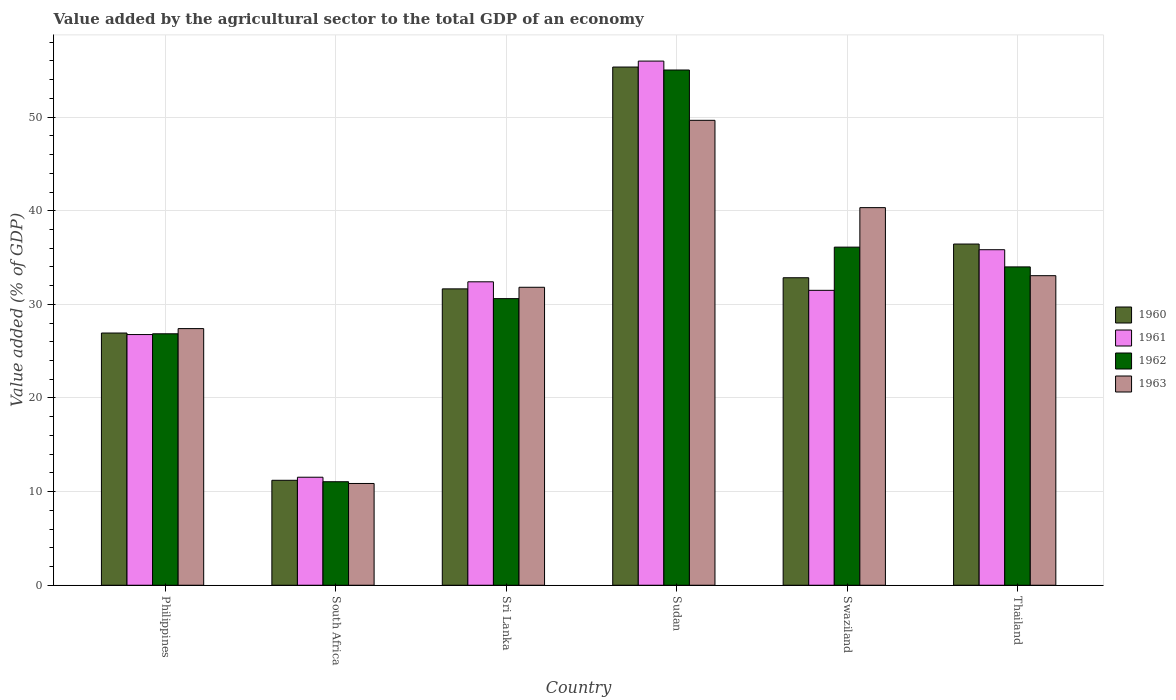Are the number of bars on each tick of the X-axis equal?
Make the answer very short. Yes. How many bars are there on the 5th tick from the left?
Your answer should be compact. 4. What is the label of the 4th group of bars from the left?
Offer a terse response. Sudan. In how many cases, is the number of bars for a given country not equal to the number of legend labels?
Your answer should be very brief. 0. What is the value added by the agricultural sector to the total GDP in 1962 in Swaziland?
Ensure brevity in your answer.  36.11. Across all countries, what is the maximum value added by the agricultural sector to the total GDP in 1963?
Give a very brief answer. 49.66. Across all countries, what is the minimum value added by the agricultural sector to the total GDP in 1961?
Offer a very short reply. 11.54. In which country was the value added by the agricultural sector to the total GDP in 1961 maximum?
Keep it short and to the point. Sudan. In which country was the value added by the agricultural sector to the total GDP in 1961 minimum?
Provide a short and direct response. South Africa. What is the total value added by the agricultural sector to the total GDP in 1960 in the graph?
Offer a terse response. 194.45. What is the difference between the value added by the agricultural sector to the total GDP in 1963 in Swaziland and that in Thailand?
Keep it short and to the point. 7.27. What is the difference between the value added by the agricultural sector to the total GDP in 1961 in South Africa and the value added by the agricultural sector to the total GDP in 1963 in Thailand?
Your response must be concise. -21.53. What is the average value added by the agricultural sector to the total GDP in 1961 per country?
Your answer should be very brief. 32.34. What is the difference between the value added by the agricultural sector to the total GDP of/in 1962 and value added by the agricultural sector to the total GDP of/in 1961 in Swaziland?
Your response must be concise. 4.61. In how many countries, is the value added by the agricultural sector to the total GDP in 1960 greater than 52 %?
Make the answer very short. 1. What is the ratio of the value added by the agricultural sector to the total GDP in 1960 in Philippines to that in Swaziland?
Keep it short and to the point. 0.82. Is the value added by the agricultural sector to the total GDP in 1963 in Philippines less than that in Sudan?
Provide a short and direct response. Yes. Is the difference between the value added by the agricultural sector to the total GDP in 1962 in South Africa and Sudan greater than the difference between the value added by the agricultural sector to the total GDP in 1961 in South Africa and Sudan?
Offer a terse response. Yes. What is the difference between the highest and the second highest value added by the agricultural sector to the total GDP in 1963?
Offer a very short reply. -9.32. What is the difference between the highest and the lowest value added by the agricultural sector to the total GDP in 1961?
Provide a succinct answer. 44.45. In how many countries, is the value added by the agricultural sector to the total GDP in 1961 greater than the average value added by the agricultural sector to the total GDP in 1961 taken over all countries?
Give a very brief answer. 3. Is it the case that in every country, the sum of the value added by the agricultural sector to the total GDP in 1963 and value added by the agricultural sector to the total GDP in 1962 is greater than the sum of value added by the agricultural sector to the total GDP in 1960 and value added by the agricultural sector to the total GDP in 1961?
Provide a succinct answer. No. What does the 1st bar from the left in Swaziland represents?
Keep it short and to the point. 1960. How many bars are there?
Your response must be concise. 24. What is the difference between two consecutive major ticks on the Y-axis?
Your response must be concise. 10. Does the graph contain grids?
Make the answer very short. Yes. Where does the legend appear in the graph?
Your answer should be very brief. Center right. How many legend labels are there?
Ensure brevity in your answer.  4. How are the legend labels stacked?
Give a very brief answer. Vertical. What is the title of the graph?
Provide a succinct answer. Value added by the agricultural sector to the total GDP of an economy. What is the label or title of the X-axis?
Provide a succinct answer. Country. What is the label or title of the Y-axis?
Ensure brevity in your answer.  Value added (% of GDP). What is the Value added (% of GDP) of 1960 in Philippines?
Your response must be concise. 26.94. What is the Value added (% of GDP) in 1961 in Philippines?
Offer a very short reply. 26.78. What is the Value added (% of GDP) of 1962 in Philippines?
Provide a short and direct response. 26.86. What is the Value added (% of GDP) in 1963 in Philippines?
Offer a very short reply. 27.41. What is the Value added (% of GDP) in 1960 in South Africa?
Your response must be concise. 11.21. What is the Value added (% of GDP) in 1961 in South Africa?
Give a very brief answer. 11.54. What is the Value added (% of GDP) of 1962 in South Africa?
Offer a terse response. 11.06. What is the Value added (% of GDP) of 1963 in South Africa?
Offer a terse response. 10.87. What is the Value added (% of GDP) in 1960 in Sri Lanka?
Offer a very short reply. 31.66. What is the Value added (% of GDP) of 1961 in Sri Lanka?
Make the answer very short. 32.41. What is the Value added (% of GDP) in 1962 in Sri Lanka?
Offer a terse response. 30.61. What is the Value added (% of GDP) of 1963 in Sri Lanka?
Provide a succinct answer. 31.83. What is the Value added (% of GDP) of 1960 in Sudan?
Your answer should be compact. 55.35. What is the Value added (% of GDP) of 1961 in Sudan?
Ensure brevity in your answer.  55.99. What is the Value added (% of GDP) in 1962 in Sudan?
Offer a very short reply. 55.03. What is the Value added (% of GDP) in 1963 in Sudan?
Offer a very short reply. 49.66. What is the Value added (% of GDP) of 1960 in Swaziland?
Ensure brevity in your answer.  32.84. What is the Value added (% of GDP) of 1961 in Swaziland?
Make the answer very short. 31.5. What is the Value added (% of GDP) of 1962 in Swaziland?
Your response must be concise. 36.11. What is the Value added (% of GDP) of 1963 in Swaziland?
Offer a very short reply. 40.33. What is the Value added (% of GDP) of 1960 in Thailand?
Provide a succinct answer. 36.44. What is the Value added (% of GDP) in 1961 in Thailand?
Your response must be concise. 35.84. What is the Value added (% of GDP) of 1962 in Thailand?
Your response must be concise. 34. What is the Value added (% of GDP) of 1963 in Thailand?
Your answer should be compact. 33.07. Across all countries, what is the maximum Value added (% of GDP) of 1960?
Your answer should be very brief. 55.35. Across all countries, what is the maximum Value added (% of GDP) of 1961?
Give a very brief answer. 55.99. Across all countries, what is the maximum Value added (% of GDP) of 1962?
Provide a short and direct response. 55.03. Across all countries, what is the maximum Value added (% of GDP) in 1963?
Provide a short and direct response. 49.66. Across all countries, what is the minimum Value added (% of GDP) of 1960?
Give a very brief answer. 11.21. Across all countries, what is the minimum Value added (% of GDP) of 1961?
Your answer should be very brief. 11.54. Across all countries, what is the minimum Value added (% of GDP) of 1962?
Make the answer very short. 11.06. Across all countries, what is the minimum Value added (% of GDP) of 1963?
Your response must be concise. 10.87. What is the total Value added (% of GDP) of 1960 in the graph?
Keep it short and to the point. 194.45. What is the total Value added (% of GDP) of 1961 in the graph?
Your response must be concise. 194.05. What is the total Value added (% of GDP) in 1962 in the graph?
Give a very brief answer. 193.68. What is the total Value added (% of GDP) in 1963 in the graph?
Your response must be concise. 193.16. What is the difference between the Value added (% of GDP) in 1960 in Philippines and that in South Africa?
Ensure brevity in your answer.  15.73. What is the difference between the Value added (% of GDP) in 1961 in Philippines and that in South Africa?
Provide a short and direct response. 15.24. What is the difference between the Value added (% of GDP) in 1962 in Philippines and that in South Africa?
Offer a terse response. 15.8. What is the difference between the Value added (% of GDP) of 1963 in Philippines and that in South Africa?
Make the answer very short. 16.54. What is the difference between the Value added (% of GDP) of 1960 in Philippines and that in Sri Lanka?
Your response must be concise. -4.72. What is the difference between the Value added (% of GDP) of 1961 in Philippines and that in Sri Lanka?
Make the answer very short. -5.63. What is the difference between the Value added (% of GDP) in 1962 in Philippines and that in Sri Lanka?
Offer a terse response. -3.76. What is the difference between the Value added (% of GDP) in 1963 in Philippines and that in Sri Lanka?
Keep it short and to the point. -4.41. What is the difference between the Value added (% of GDP) of 1960 in Philippines and that in Sudan?
Your answer should be compact. -28.41. What is the difference between the Value added (% of GDP) in 1961 in Philippines and that in Sudan?
Your answer should be very brief. -29.21. What is the difference between the Value added (% of GDP) of 1962 in Philippines and that in Sudan?
Your answer should be compact. -28.18. What is the difference between the Value added (% of GDP) in 1963 in Philippines and that in Sudan?
Offer a terse response. -22.25. What is the difference between the Value added (% of GDP) in 1960 in Philippines and that in Swaziland?
Provide a succinct answer. -5.9. What is the difference between the Value added (% of GDP) of 1961 in Philippines and that in Swaziland?
Offer a terse response. -4.72. What is the difference between the Value added (% of GDP) of 1962 in Philippines and that in Swaziland?
Provide a short and direct response. -9.26. What is the difference between the Value added (% of GDP) in 1963 in Philippines and that in Swaziland?
Your response must be concise. -12.92. What is the difference between the Value added (% of GDP) in 1960 in Philippines and that in Thailand?
Your answer should be compact. -9.5. What is the difference between the Value added (% of GDP) in 1961 in Philippines and that in Thailand?
Offer a terse response. -9.06. What is the difference between the Value added (% of GDP) in 1962 in Philippines and that in Thailand?
Your response must be concise. -7.14. What is the difference between the Value added (% of GDP) in 1963 in Philippines and that in Thailand?
Your answer should be compact. -5.65. What is the difference between the Value added (% of GDP) in 1960 in South Africa and that in Sri Lanka?
Your answer should be very brief. -20.45. What is the difference between the Value added (% of GDP) of 1961 in South Africa and that in Sri Lanka?
Your answer should be compact. -20.87. What is the difference between the Value added (% of GDP) in 1962 in South Africa and that in Sri Lanka?
Keep it short and to the point. -19.56. What is the difference between the Value added (% of GDP) in 1963 in South Africa and that in Sri Lanka?
Offer a terse response. -20.96. What is the difference between the Value added (% of GDP) in 1960 in South Africa and that in Sudan?
Provide a succinct answer. -44.14. What is the difference between the Value added (% of GDP) in 1961 in South Africa and that in Sudan?
Your response must be concise. -44.45. What is the difference between the Value added (% of GDP) in 1962 in South Africa and that in Sudan?
Make the answer very short. -43.98. What is the difference between the Value added (% of GDP) of 1963 in South Africa and that in Sudan?
Your response must be concise. -38.79. What is the difference between the Value added (% of GDP) of 1960 in South Africa and that in Swaziland?
Your response must be concise. -21.63. What is the difference between the Value added (% of GDP) in 1961 in South Africa and that in Swaziland?
Provide a short and direct response. -19.96. What is the difference between the Value added (% of GDP) in 1962 in South Africa and that in Swaziland?
Ensure brevity in your answer.  -25.06. What is the difference between the Value added (% of GDP) of 1963 in South Africa and that in Swaziland?
Ensure brevity in your answer.  -29.46. What is the difference between the Value added (% of GDP) in 1960 in South Africa and that in Thailand?
Keep it short and to the point. -25.23. What is the difference between the Value added (% of GDP) in 1961 in South Africa and that in Thailand?
Offer a terse response. -24.3. What is the difference between the Value added (% of GDP) of 1962 in South Africa and that in Thailand?
Your response must be concise. -22.95. What is the difference between the Value added (% of GDP) in 1963 in South Africa and that in Thailand?
Provide a short and direct response. -22.2. What is the difference between the Value added (% of GDP) in 1960 in Sri Lanka and that in Sudan?
Offer a terse response. -23.7. What is the difference between the Value added (% of GDP) of 1961 in Sri Lanka and that in Sudan?
Your answer should be very brief. -23.58. What is the difference between the Value added (% of GDP) of 1962 in Sri Lanka and that in Sudan?
Give a very brief answer. -24.42. What is the difference between the Value added (% of GDP) of 1963 in Sri Lanka and that in Sudan?
Keep it short and to the point. -17.83. What is the difference between the Value added (% of GDP) of 1960 in Sri Lanka and that in Swaziland?
Keep it short and to the point. -1.19. What is the difference between the Value added (% of GDP) of 1961 in Sri Lanka and that in Swaziland?
Your response must be concise. 0.91. What is the difference between the Value added (% of GDP) in 1962 in Sri Lanka and that in Swaziland?
Offer a terse response. -5.5. What is the difference between the Value added (% of GDP) in 1963 in Sri Lanka and that in Swaziland?
Your answer should be very brief. -8.51. What is the difference between the Value added (% of GDP) in 1960 in Sri Lanka and that in Thailand?
Ensure brevity in your answer.  -4.79. What is the difference between the Value added (% of GDP) in 1961 in Sri Lanka and that in Thailand?
Your answer should be compact. -3.43. What is the difference between the Value added (% of GDP) of 1962 in Sri Lanka and that in Thailand?
Your response must be concise. -3.39. What is the difference between the Value added (% of GDP) in 1963 in Sri Lanka and that in Thailand?
Offer a terse response. -1.24. What is the difference between the Value added (% of GDP) in 1960 in Sudan and that in Swaziland?
Provide a succinct answer. 22.51. What is the difference between the Value added (% of GDP) of 1961 in Sudan and that in Swaziland?
Your answer should be compact. 24.49. What is the difference between the Value added (% of GDP) in 1962 in Sudan and that in Swaziland?
Your response must be concise. 18.92. What is the difference between the Value added (% of GDP) in 1963 in Sudan and that in Swaziland?
Provide a short and direct response. 9.32. What is the difference between the Value added (% of GDP) in 1960 in Sudan and that in Thailand?
Your answer should be very brief. 18.91. What is the difference between the Value added (% of GDP) in 1961 in Sudan and that in Thailand?
Keep it short and to the point. 20.15. What is the difference between the Value added (% of GDP) in 1962 in Sudan and that in Thailand?
Ensure brevity in your answer.  21.03. What is the difference between the Value added (% of GDP) of 1963 in Sudan and that in Thailand?
Give a very brief answer. 16.59. What is the difference between the Value added (% of GDP) of 1960 in Swaziland and that in Thailand?
Make the answer very short. -3.6. What is the difference between the Value added (% of GDP) of 1961 in Swaziland and that in Thailand?
Your response must be concise. -4.34. What is the difference between the Value added (% of GDP) in 1962 in Swaziland and that in Thailand?
Keep it short and to the point. 2.11. What is the difference between the Value added (% of GDP) of 1963 in Swaziland and that in Thailand?
Your response must be concise. 7.27. What is the difference between the Value added (% of GDP) of 1960 in Philippines and the Value added (% of GDP) of 1961 in South Africa?
Your response must be concise. 15.4. What is the difference between the Value added (% of GDP) in 1960 in Philippines and the Value added (% of GDP) in 1962 in South Africa?
Your answer should be very brief. 15.88. What is the difference between the Value added (% of GDP) of 1960 in Philippines and the Value added (% of GDP) of 1963 in South Africa?
Make the answer very short. 16.07. What is the difference between the Value added (% of GDP) in 1961 in Philippines and the Value added (% of GDP) in 1962 in South Africa?
Ensure brevity in your answer.  15.72. What is the difference between the Value added (% of GDP) of 1961 in Philippines and the Value added (% of GDP) of 1963 in South Africa?
Offer a very short reply. 15.91. What is the difference between the Value added (% of GDP) in 1962 in Philippines and the Value added (% of GDP) in 1963 in South Africa?
Keep it short and to the point. 15.99. What is the difference between the Value added (% of GDP) of 1960 in Philippines and the Value added (% of GDP) of 1961 in Sri Lanka?
Make the answer very short. -5.47. What is the difference between the Value added (% of GDP) of 1960 in Philippines and the Value added (% of GDP) of 1962 in Sri Lanka?
Your response must be concise. -3.67. What is the difference between the Value added (% of GDP) of 1960 in Philippines and the Value added (% of GDP) of 1963 in Sri Lanka?
Give a very brief answer. -4.89. What is the difference between the Value added (% of GDP) of 1961 in Philippines and the Value added (% of GDP) of 1962 in Sri Lanka?
Make the answer very short. -3.84. What is the difference between the Value added (% of GDP) of 1961 in Philippines and the Value added (% of GDP) of 1963 in Sri Lanka?
Your answer should be compact. -5.05. What is the difference between the Value added (% of GDP) of 1962 in Philippines and the Value added (% of GDP) of 1963 in Sri Lanka?
Ensure brevity in your answer.  -4.97. What is the difference between the Value added (% of GDP) in 1960 in Philippines and the Value added (% of GDP) in 1961 in Sudan?
Provide a succinct answer. -29.05. What is the difference between the Value added (% of GDP) in 1960 in Philippines and the Value added (% of GDP) in 1962 in Sudan?
Offer a very short reply. -28.09. What is the difference between the Value added (% of GDP) of 1960 in Philippines and the Value added (% of GDP) of 1963 in Sudan?
Your answer should be compact. -22.72. What is the difference between the Value added (% of GDP) in 1961 in Philippines and the Value added (% of GDP) in 1962 in Sudan?
Give a very brief answer. -28.26. What is the difference between the Value added (% of GDP) of 1961 in Philippines and the Value added (% of GDP) of 1963 in Sudan?
Ensure brevity in your answer.  -22.88. What is the difference between the Value added (% of GDP) in 1962 in Philippines and the Value added (% of GDP) in 1963 in Sudan?
Your answer should be compact. -22.8. What is the difference between the Value added (% of GDP) of 1960 in Philippines and the Value added (% of GDP) of 1961 in Swaziland?
Offer a very short reply. -4.56. What is the difference between the Value added (% of GDP) in 1960 in Philippines and the Value added (% of GDP) in 1962 in Swaziland?
Give a very brief answer. -9.17. What is the difference between the Value added (% of GDP) in 1960 in Philippines and the Value added (% of GDP) in 1963 in Swaziland?
Your answer should be compact. -13.39. What is the difference between the Value added (% of GDP) in 1961 in Philippines and the Value added (% of GDP) in 1962 in Swaziland?
Keep it short and to the point. -9.34. What is the difference between the Value added (% of GDP) in 1961 in Philippines and the Value added (% of GDP) in 1963 in Swaziland?
Make the answer very short. -13.56. What is the difference between the Value added (% of GDP) of 1962 in Philippines and the Value added (% of GDP) of 1963 in Swaziland?
Your response must be concise. -13.48. What is the difference between the Value added (% of GDP) in 1960 in Philippines and the Value added (% of GDP) in 1961 in Thailand?
Offer a terse response. -8.9. What is the difference between the Value added (% of GDP) in 1960 in Philippines and the Value added (% of GDP) in 1962 in Thailand?
Offer a very short reply. -7.06. What is the difference between the Value added (% of GDP) in 1960 in Philippines and the Value added (% of GDP) in 1963 in Thailand?
Provide a short and direct response. -6.12. What is the difference between the Value added (% of GDP) in 1961 in Philippines and the Value added (% of GDP) in 1962 in Thailand?
Your answer should be compact. -7.23. What is the difference between the Value added (% of GDP) in 1961 in Philippines and the Value added (% of GDP) in 1963 in Thailand?
Ensure brevity in your answer.  -6.29. What is the difference between the Value added (% of GDP) in 1962 in Philippines and the Value added (% of GDP) in 1963 in Thailand?
Ensure brevity in your answer.  -6.21. What is the difference between the Value added (% of GDP) of 1960 in South Africa and the Value added (% of GDP) of 1961 in Sri Lanka?
Provide a short and direct response. -21.2. What is the difference between the Value added (% of GDP) of 1960 in South Africa and the Value added (% of GDP) of 1962 in Sri Lanka?
Ensure brevity in your answer.  -19.4. What is the difference between the Value added (% of GDP) in 1960 in South Africa and the Value added (% of GDP) in 1963 in Sri Lanka?
Give a very brief answer. -20.62. What is the difference between the Value added (% of GDP) of 1961 in South Africa and the Value added (% of GDP) of 1962 in Sri Lanka?
Give a very brief answer. -19.08. What is the difference between the Value added (% of GDP) of 1961 in South Africa and the Value added (% of GDP) of 1963 in Sri Lanka?
Provide a short and direct response. -20.29. What is the difference between the Value added (% of GDP) of 1962 in South Africa and the Value added (% of GDP) of 1963 in Sri Lanka?
Your answer should be compact. -20.77. What is the difference between the Value added (% of GDP) of 1960 in South Africa and the Value added (% of GDP) of 1961 in Sudan?
Your answer should be very brief. -44.78. What is the difference between the Value added (% of GDP) in 1960 in South Africa and the Value added (% of GDP) in 1962 in Sudan?
Keep it short and to the point. -43.82. What is the difference between the Value added (% of GDP) of 1960 in South Africa and the Value added (% of GDP) of 1963 in Sudan?
Keep it short and to the point. -38.45. What is the difference between the Value added (% of GDP) in 1961 in South Africa and the Value added (% of GDP) in 1962 in Sudan?
Provide a succinct answer. -43.5. What is the difference between the Value added (% of GDP) in 1961 in South Africa and the Value added (% of GDP) in 1963 in Sudan?
Your answer should be very brief. -38.12. What is the difference between the Value added (% of GDP) of 1962 in South Africa and the Value added (% of GDP) of 1963 in Sudan?
Your answer should be very brief. -38.6. What is the difference between the Value added (% of GDP) of 1960 in South Africa and the Value added (% of GDP) of 1961 in Swaziland?
Give a very brief answer. -20.29. What is the difference between the Value added (% of GDP) in 1960 in South Africa and the Value added (% of GDP) in 1962 in Swaziland?
Give a very brief answer. -24.9. What is the difference between the Value added (% of GDP) in 1960 in South Africa and the Value added (% of GDP) in 1963 in Swaziland?
Ensure brevity in your answer.  -29.12. What is the difference between the Value added (% of GDP) of 1961 in South Africa and the Value added (% of GDP) of 1962 in Swaziland?
Offer a terse response. -24.58. What is the difference between the Value added (% of GDP) of 1961 in South Africa and the Value added (% of GDP) of 1963 in Swaziland?
Your response must be concise. -28.8. What is the difference between the Value added (% of GDP) in 1962 in South Africa and the Value added (% of GDP) in 1963 in Swaziland?
Provide a succinct answer. -29.28. What is the difference between the Value added (% of GDP) of 1960 in South Africa and the Value added (% of GDP) of 1961 in Thailand?
Give a very brief answer. -24.63. What is the difference between the Value added (% of GDP) of 1960 in South Africa and the Value added (% of GDP) of 1962 in Thailand?
Provide a short and direct response. -22.79. What is the difference between the Value added (% of GDP) in 1960 in South Africa and the Value added (% of GDP) in 1963 in Thailand?
Keep it short and to the point. -21.86. What is the difference between the Value added (% of GDP) of 1961 in South Africa and the Value added (% of GDP) of 1962 in Thailand?
Your response must be concise. -22.47. What is the difference between the Value added (% of GDP) of 1961 in South Africa and the Value added (% of GDP) of 1963 in Thailand?
Make the answer very short. -21.53. What is the difference between the Value added (% of GDP) of 1962 in South Africa and the Value added (% of GDP) of 1963 in Thailand?
Keep it short and to the point. -22.01. What is the difference between the Value added (% of GDP) in 1960 in Sri Lanka and the Value added (% of GDP) in 1961 in Sudan?
Keep it short and to the point. -24.33. What is the difference between the Value added (% of GDP) in 1960 in Sri Lanka and the Value added (% of GDP) in 1962 in Sudan?
Keep it short and to the point. -23.38. What is the difference between the Value added (% of GDP) in 1960 in Sri Lanka and the Value added (% of GDP) in 1963 in Sudan?
Provide a succinct answer. -18. What is the difference between the Value added (% of GDP) of 1961 in Sri Lanka and the Value added (% of GDP) of 1962 in Sudan?
Provide a succinct answer. -22.62. What is the difference between the Value added (% of GDP) of 1961 in Sri Lanka and the Value added (% of GDP) of 1963 in Sudan?
Your answer should be compact. -17.25. What is the difference between the Value added (% of GDP) in 1962 in Sri Lanka and the Value added (% of GDP) in 1963 in Sudan?
Provide a succinct answer. -19.04. What is the difference between the Value added (% of GDP) in 1960 in Sri Lanka and the Value added (% of GDP) in 1961 in Swaziland?
Your answer should be very brief. 0.16. What is the difference between the Value added (% of GDP) in 1960 in Sri Lanka and the Value added (% of GDP) in 1962 in Swaziland?
Provide a succinct answer. -4.46. What is the difference between the Value added (% of GDP) in 1960 in Sri Lanka and the Value added (% of GDP) in 1963 in Swaziland?
Keep it short and to the point. -8.68. What is the difference between the Value added (% of GDP) in 1961 in Sri Lanka and the Value added (% of GDP) in 1962 in Swaziland?
Keep it short and to the point. -3.7. What is the difference between the Value added (% of GDP) in 1961 in Sri Lanka and the Value added (% of GDP) in 1963 in Swaziland?
Make the answer very short. -7.92. What is the difference between the Value added (% of GDP) in 1962 in Sri Lanka and the Value added (% of GDP) in 1963 in Swaziland?
Ensure brevity in your answer.  -9.72. What is the difference between the Value added (% of GDP) of 1960 in Sri Lanka and the Value added (% of GDP) of 1961 in Thailand?
Provide a short and direct response. -4.18. What is the difference between the Value added (% of GDP) of 1960 in Sri Lanka and the Value added (% of GDP) of 1962 in Thailand?
Ensure brevity in your answer.  -2.35. What is the difference between the Value added (% of GDP) in 1960 in Sri Lanka and the Value added (% of GDP) in 1963 in Thailand?
Your response must be concise. -1.41. What is the difference between the Value added (% of GDP) of 1961 in Sri Lanka and the Value added (% of GDP) of 1962 in Thailand?
Ensure brevity in your answer.  -1.59. What is the difference between the Value added (% of GDP) of 1961 in Sri Lanka and the Value added (% of GDP) of 1963 in Thailand?
Ensure brevity in your answer.  -0.65. What is the difference between the Value added (% of GDP) in 1962 in Sri Lanka and the Value added (% of GDP) in 1963 in Thailand?
Give a very brief answer. -2.45. What is the difference between the Value added (% of GDP) of 1960 in Sudan and the Value added (% of GDP) of 1961 in Swaziland?
Ensure brevity in your answer.  23.85. What is the difference between the Value added (% of GDP) of 1960 in Sudan and the Value added (% of GDP) of 1962 in Swaziland?
Offer a terse response. 19.24. What is the difference between the Value added (% of GDP) of 1960 in Sudan and the Value added (% of GDP) of 1963 in Swaziland?
Offer a terse response. 15.02. What is the difference between the Value added (% of GDP) in 1961 in Sudan and the Value added (% of GDP) in 1962 in Swaziland?
Ensure brevity in your answer.  19.87. What is the difference between the Value added (% of GDP) of 1961 in Sudan and the Value added (% of GDP) of 1963 in Swaziland?
Your answer should be compact. 15.65. What is the difference between the Value added (% of GDP) in 1962 in Sudan and the Value added (% of GDP) in 1963 in Swaziland?
Give a very brief answer. 14.7. What is the difference between the Value added (% of GDP) of 1960 in Sudan and the Value added (% of GDP) of 1961 in Thailand?
Provide a short and direct response. 19.51. What is the difference between the Value added (% of GDP) in 1960 in Sudan and the Value added (% of GDP) in 1962 in Thailand?
Provide a succinct answer. 21.35. What is the difference between the Value added (% of GDP) of 1960 in Sudan and the Value added (% of GDP) of 1963 in Thailand?
Give a very brief answer. 22.29. What is the difference between the Value added (% of GDP) of 1961 in Sudan and the Value added (% of GDP) of 1962 in Thailand?
Offer a terse response. 21.98. What is the difference between the Value added (% of GDP) in 1961 in Sudan and the Value added (% of GDP) in 1963 in Thailand?
Offer a terse response. 22.92. What is the difference between the Value added (% of GDP) of 1962 in Sudan and the Value added (% of GDP) of 1963 in Thailand?
Offer a very short reply. 21.97. What is the difference between the Value added (% of GDP) of 1960 in Swaziland and the Value added (% of GDP) of 1961 in Thailand?
Ensure brevity in your answer.  -2.99. What is the difference between the Value added (% of GDP) in 1960 in Swaziland and the Value added (% of GDP) in 1962 in Thailand?
Your answer should be very brief. -1.16. What is the difference between the Value added (% of GDP) in 1960 in Swaziland and the Value added (% of GDP) in 1963 in Thailand?
Make the answer very short. -0.22. What is the difference between the Value added (% of GDP) in 1961 in Swaziland and the Value added (% of GDP) in 1962 in Thailand?
Provide a succinct answer. -2.5. What is the difference between the Value added (% of GDP) of 1961 in Swaziland and the Value added (% of GDP) of 1963 in Thailand?
Your answer should be compact. -1.57. What is the difference between the Value added (% of GDP) of 1962 in Swaziland and the Value added (% of GDP) of 1963 in Thailand?
Keep it short and to the point. 3.05. What is the average Value added (% of GDP) in 1960 per country?
Provide a short and direct response. 32.41. What is the average Value added (% of GDP) of 1961 per country?
Your answer should be compact. 32.34. What is the average Value added (% of GDP) in 1962 per country?
Provide a succinct answer. 32.28. What is the average Value added (% of GDP) in 1963 per country?
Offer a very short reply. 32.19. What is the difference between the Value added (% of GDP) of 1960 and Value added (% of GDP) of 1961 in Philippines?
Make the answer very short. 0.16. What is the difference between the Value added (% of GDP) of 1960 and Value added (% of GDP) of 1962 in Philippines?
Keep it short and to the point. 0.08. What is the difference between the Value added (% of GDP) of 1960 and Value added (% of GDP) of 1963 in Philippines?
Offer a very short reply. -0.47. What is the difference between the Value added (% of GDP) of 1961 and Value added (% of GDP) of 1962 in Philippines?
Keep it short and to the point. -0.08. What is the difference between the Value added (% of GDP) in 1961 and Value added (% of GDP) in 1963 in Philippines?
Make the answer very short. -0.64. What is the difference between the Value added (% of GDP) in 1962 and Value added (% of GDP) in 1963 in Philippines?
Your answer should be very brief. -0.55. What is the difference between the Value added (% of GDP) in 1960 and Value added (% of GDP) in 1961 in South Africa?
Make the answer very short. -0.33. What is the difference between the Value added (% of GDP) in 1960 and Value added (% of GDP) in 1962 in South Africa?
Keep it short and to the point. 0.15. What is the difference between the Value added (% of GDP) of 1960 and Value added (% of GDP) of 1963 in South Africa?
Your answer should be very brief. 0.34. What is the difference between the Value added (% of GDP) of 1961 and Value added (% of GDP) of 1962 in South Africa?
Make the answer very short. 0.48. What is the difference between the Value added (% of GDP) of 1961 and Value added (% of GDP) of 1963 in South Africa?
Your response must be concise. 0.67. What is the difference between the Value added (% of GDP) in 1962 and Value added (% of GDP) in 1963 in South Africa?
Your answer should be compact. 0.19. What is the difference between the Value added (% of GDP) in 1960 and Value added (% of GDP) in 1961 in Sri Lanka?
Your response must be concise. -0.76. What is the difference between the Value added (% of GDP) in 1960 and Value added (% of GDP) in 1962 in Sri Lanka?
Ensure brevity in your answer.  1.04. What is the difference between the Value added (% of GDP) of 1960 and Value added (% of GDP) of 1963 in Sri Lanka?
Make the answer very short. -0.17. What is the difference between the Value added (% of GDP) in 1961 and Value added (% of GDP) in 1962 in Sri Lanka?
Give a very brief answer. 1.8. What is the difference between the Value added (% of GDP) in 1961 and Value added (% of GDP) in 1963 in Sri Lanka?
Keep it short and to the point. 0.59. What is the difference between the Value added (% of GDP) of 1962 and Value added (% of GDP) of 1963 in Sri Lanka?
Offer a very short reply. -1.21. What is the difference between the Value added (% of GDP) in 1960 and Value added (% of GDP) in 1961 in Sudan?
Your answer should be compact. -0.64. What is the difference between the Value added (% of GDP) of 1960 and Value added (% of GDP) of 1962 in Sudan?
Offer a terse response. 0.32. What is the difference between the Value added (% of GDP) of 1960 and Value added (% of GDP) of 1963 in Sudan?
Offer a terse response. 5.69. What is the difference between the Value added (% of GDP) of 1961 and Value added (% of GDP) of 1962 in Sudan?
Ensure brevity in your answer.  0.95. What is the difference between the Value added (% of GDP) in 1961 and Value added (% of GDP) in 1963 in Sudan?
Provide a short and direct response. 6.33. What is the difference between the Value added (% of GDP) of 1962 and Value added (% of GDP) of 1963 in Sudan?
Give a very brief answer. 5.37. What is the difference between the Value added (% of GDP) of 1960 and Value added (% of GDP) of 1961 in Swaziland?
Make the answer very short. 1.35. What is the difference between the Value added (% of GDP) in 1960 and Value added (% of GDP) in 1962 in Swaziland?
Offer a very short reply. -3.27. What is the difference between the Value added (% of GDP) in 1960 and Value added (% of GDP) in 1963 in Swaziland?
Your response must be concise. -7.49. What is the difference between the Value added (% of GDP) in 1961 and Value added (% of GDP) in 1962 in Swaziland?
Your answer should be very brief. -4.61. What is the difference between the Value added (% of GDP) of 1961 and Value added (% of GDP) of 1963 in Swaziland?
Provide a short and direct response. -8.83. What is the difference between the Value added (% of GDP) in 1962 and Value added (% of GDP) in 1963 in Swaziland?
Provide a succinct answer. -4.22. What is the difference between the Value added (% of GDP) of 1960 and Value added (% of GDP) of 1961 in Thailand?
Provide a succinct answer. 0.61. What is the difference between the Value added (% of GDP) of 1960 and Value added (% of GDP) of 1962 in Thailand?
Give a very brief answer. 2.44. What is the difference between the Value added (% of GDP) of 1960 and Value added (% of GDP) of 1963 in Thailand?
Your answer should be compact. 3.38. What is the difference between the Value added (% of GDP) of 1961 and Value added (% of GDP) of 1962 in Thailand?
Make the answer very short. 1.84. What is the difference between the Value added (% of GDP) of 1961 and Value added (% of GDP) of 1963 in Thailand?
Keep it short and to the point. 2.77. What is the difference between the Value added (% of GDP) of 1962 and Value added (% of GDP) of 1963 in Thailand?
Ensure brevity in your answer.  0.94. What is the ratio of the Value added (% of GDP) in 1960 in Philippines to that in South Africa?
Your response must be concise. 2.4. What is the ratio of the Value added (% of GDP) of 1961 in Philippines to that in South Africa?
Your answer should be compact. 2.32. What is the ratio of the Value added (% of GDP) of 1962 in Philippines to that in South Africa?
Give a very brief answer. 2.43. What is the ratio of the Value added (% of GDP) in 1963 in Philippines to that in South Africa?
Provide a succinct answer. 2.52. What is the ratio of the Value added (% of GDP) in 1960 in Philippines to that in Sri Lanka?
Keep it short and to the point. 0.85. What is the ratio of the Value added (% of GDP) in 1961 in Philippines to that in Sri Lanka?
Offer a very short reply. 0.83. What is the ratio of the Value added (% of GDP) in 1962 in Philippines to that in Sri Lanka?
Provide a short and direct response. 0.88. What is the ratio of the Value added (% of GDP) in 1963 in Philippines to that in Sri Lanka?
Give a very brief answer. 0.86. What is the ratio of the Value added (% of GDP) of 1960 in Philippines to that in Sudan?
Provide a succinct answer. 0.49. What is the ratio of the Value added (% of GDP) in 1961 in Philippines to that in Sudan?
Offer a terse response. 0.48. What is the ratio of the Value added (% of GDP) of 1962 in Philippines to that in Sudan?
Ensure brevity in your answer.  0.49. What is the ratio of the Value added (% of GDP) in 1963 in Philippines to that in Sudan?
Provide a succinct answer. 0.55. What is the ratio of the Value added (% of GDP) of 1960 in Philippines to that in Swaziland?
Your answer should be very brief. 0.82. What is the ratio of the Value added (% of GDP) of 1961 in Philippines to that in Swaziland?
Provide a succinct answer. 0.85. What is the ratio of the Value added (% of GDP) in 1962 in Philippines to that in Swaziland?
Your answer should be very brief. 0.74. What is the ratio of the Value added (% of GDP) in 1963 in Philippines to that in Swaziland?
Your response must be concise. 0.68. What is the ratio of the Value added (% of GDP) of 1960 in Philippines to that in Thailand?
Ensure brevity in your answer.  0.74. What is the ratio of the Value added (% of GDP) of 1961 in Philippines to that in Thailand?
Give a very brief answer. 0.75. What is the ratio of the Value added (% of GDP) of 1962 in Philippines to that in Thailand?
Provide a succinct answer. 0.79. What is the ratio of the Value added (% of GDP) of 1963 in Philippines to that in Thailand?
Provide a succinct answer. 0.83. What is the ratio of the Value added (% of GDP) of 1960 in South Africa to that in Sri Lanka?
Your response must be concise. 0.35. What is the ratio of the Value added (% of GDP) in 1961 in South Africa to that in Sri Lanka?
Offer a terse response. 0.36. What is the ratio of the Value added (% of GDP) in 1962 in South Africa to that in Sri Lanka?
Offer a terse response. 0.36. What is the ratio of the Value added (% of GDP) in 1963 in South Africa to that in Sri Lanka?
Provide a short and direct response. 0.34. What is the ratio of the Value added (% of GDP) of 1960 in South Africa to that in Sudan?
Ensure brevity in your answer.  0.2. What is the ratio of the Value added (% of GDP) of 1961 in South Africa to that in Sudan?
Offer a terse response. 0.21. What is the ratio of the Value added (% of GDP) of 1962 in South Africa to that in Sudan?
Offer a very short reply. 0.2. What is the ratio of the Value added (% of GDP) of 1963 in South Africa to that in Sudan?
Make the answer very short. 0.22. What is the ratio of the Value added (% of GDP) in 1960 in South Africa to that in Swaziland?
Provide a succinct answer. 0.34. What is the ratio of the Value added (% of GDP) of 1961 in South Africa to that in Swaziland?
Offer a very short reply. 0.37. What is the ratio of the Value added (% of GDP) of 1962 in South Africa to that in Swaziland?
Your answer should be compact. 0.31. What is the ratio of the Value added (% of GDP) in 1963 in South Africa to that in Swaziland?
Your response must be concise. 0.27. What is the ratio of the Value added (% of GDP) in 1960 in South Africa to that in Thailand?
Offer a terse response. 0.31. What is the ratio of the Value added (% of GDP) in 1961 in South Africa to that in Thailand?
Ensure brevity in your answer.  0.32. What is the ratio of the Value added (% of GDP) in 1962 in South Africa to that in Thailand?
Provide a succinct answer. 0.33. What is the ratio of the Value added (% of GDP) of 1963 in South Africa to that in Thailand?
Your answer should be very brief. 0.33. What is the ratio of the Value added (% of GDP) in 1960 in Sri Lanka to that in Sudan?
Provide a succinct answer. 0.57. What is the ratio of the Value added (% of GDP) of 1961 in Sri Lanka to that in Sudan?
Offer a very short reply. 0.58. What is the ratio of the Value added (% of GDP) in 1962 in Sri Lanka to that in Sudan?
Provide a succinct answer. 0.56. What is the ratio of the Value added (% of GDP) of 1963 in Sri Lanka to that in Sudan?
Offer a terse response. 0.64. What is the ratio of the Value added (% of GDP) in 1960 in Sri Lanka to that in Swaziland?
Offer a very short reply. 0.96. What is the ratio of the Value added (% of GDP) in 1961 in Sri Lanka to that in Swaziland?
Ensure brevity in your answer.  1.03. What is the ratio of the Value added (% of GDP) in 1962 in Sri Lanka to that in Swaziland?
Your response must be concise. 0.85. What is the ratio of the Value added (% of GDP) in 1963 in Sri Lanka to that in Swaziland?
Provide a succinct answer. 0.79. What is the ratio of the Value added (% of GDP) of 1960 in Sri Lanka to that in Thailand?
Your response must be concise. 0.87. What is the ratio of the Value added (% of GDP) of 1961 in Sri Lanka to that in Thailand?
Give a very brief answer. 0.9. What is the ratio of the Value added (% of GDP) of 1962 in Sri Lanka to that in Thailand?
Keep it short and to the point. 0.9. What is the ratio of the Value added (% of GDP) of 1963 in Sri Lanka to that in Thailand?
Keep it short and to the point. 0.96. What is the ratio of the Value added (% of GDP) of 1960 in Sudan to that in Swaziland?
Ensure brevity in your answer.  1.69. What is the ratio of the Value added (% of GDP) in 1961 in Sudan to that in Swaziland?
Make the answer very short. 1.78. What is the ratio of the Value added (% of GDP) of 1962 in Sudan to that in Swaziland?
Your answer should be very brief. 1.52. What is the ratio of the Value added (% of GDP) of 1963 in Sudan to that in Swaziland?
Offer a very short reply. 1.23. What is the ratio of the Value added (% of GDP) of 1960 in Sudan to that in Thailand?
Provide a succinct answer. 1.52. What is the ratio of the Value added (% of GDP) in 1961 in Sudan to that in Thailand?
Provide a short and direct response. 1.56. What is the ratio of the Value added (% of GDP) in 1962 in Sudan to that in Thailand?
Make the answer very short. 1.62. What is the ratio of the Value added (% of GDP) in 1963 in Sudan to that in Thailand?
Make the answer very short. 1.5. What is the ratio of the Value added (% of GDP) in 1960 in Swaziland to that in Thailand?
Your answer should be very brief. 0.9. What is the ratio of the Value added (% of GDP) in 1961 in Swaziland to that in Thailand?
Ensure brevity in your answer.  0.88. What is the ratio of the Value added (% of GDP) of 1962 in Swaziland to that in Thailand?
Keep it short and to the point. 1.06. What is the ratio of the Value added (% of GDP) in 1963 in Swaziland to that in Thailand?
Your response must be concise. 1.22. What is the difference between the highest and the second highest Value added (% of GDP) of 1960?
Provide a short and direct response. 18.91. What is the difference between the highest and the second highest Value added (% of GDP) in 1961?
Offer a terse response. 20.15. What is the difference between the highest and the second highest Value added (% of GDP) in 1962?
Make the answer very short. 18.92. What is the difference between the highest and the second highest Value added (% of GDP) in 1963?
Keep it short and to the point. 9.32. What is the difference between the highest and the lowest Value added (% of GDP) in 1960?
Your answer should be very brief. 44.14. What is the difference between the highest and the lowest Value added (% of GDP) of 1961?
Ensure brevity in your answer.  44.45. What is the difference between the highest and the lowest Value added (% of GDP) of 1962?
Offer a terse response. 43.98. What is the difference between the highest and the lowest Value added (% of GDP) of 1963?
Provide a succinct answer. 38.79. 